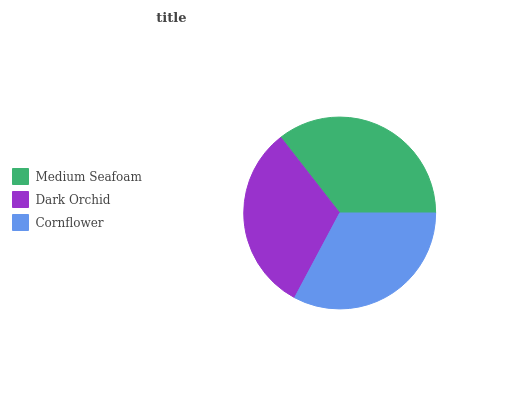Is Dark Orchid the minimum?
Answer yes or no. Yes. Is Medium Seafoam the maximum?
Answer yes or no. Yes. Is Cornflower the minimum?
Answer yes or no. No. Is Cornflower the maximum?
Answer yes or no. No. Is Cornflower greater than Dark Orchid?
Answer yes or no. Yes. Is Dark Orchid less than Cornflower?
Answer yes or no. Yes. Is Dark Orchid greater than Cornflower?
Answer yes or no. No. Is Cornflower less than Dark Orchid?
Answer yes or no. No. Is Cornflower the high median?
Answer yes or no. Yes. Is Cornflower the low median?
Answer yes or no. Yes. Is Medium Seafoam the high median?
Answer yes or no. No. Is Medium Seafoam the low median?
Answer yes or no. No. 